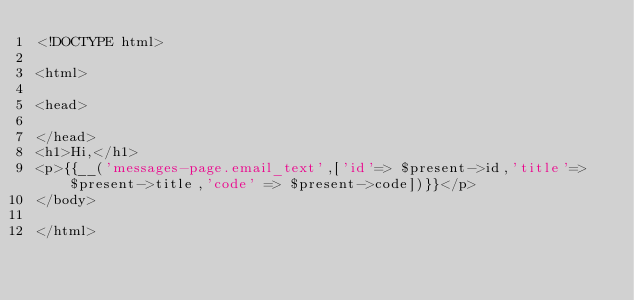<code> <loc_0><loc_0><loc_500><loc_500><_PHP_><!DOCTYPE html>

<html>

<head>

</head>
<h1>Hi,</h1>
<p>{{__('messages-page.email_text',['id'=> $present->id,'title'=>$present->title,'code' => $present->code])}}</p>
</body>

</html>
</code> 